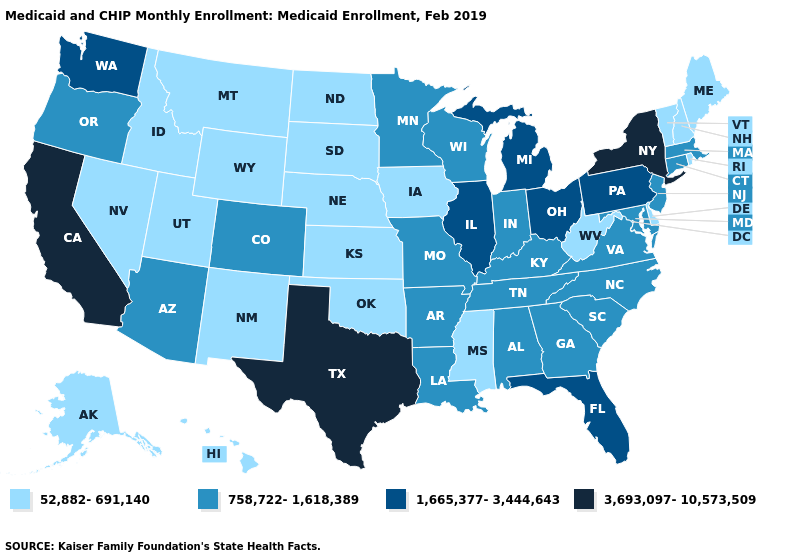Does Alabama have a lower value than Connecticut?
Short answer required. No. What is the highest value in states that border Kansas?
Be succinct. 758,722-1,618,389. Does the map have missing data?
Keep it brief. No. What is the value of West Virginia?
Be succinct. 52,882-691,140. Name the states that have a value in the range 52,882-691,140?
Short answer required. Alaska, Delaware, Hawaii, Idaho, Iowa, Kansas, Maine, Mississippi, Montana, Nebraska, Nevada, New Hampshire, New Mexico, North Dakota, Oklahoma, Rhode Island, South Dakota, Utah, Vermont, West Virginia, Wyoming. What is the value of Tennessee?
Be succinct. 758,722-1,618,389. Does Idaho have the same value as Washington?
Give a very brief answer. No. What is the value of New Jersey?
Keep it brief. 758,722-1,618,389. What is the value of Utah?
Short answer required. 52,882-691,140. Does Missouri have the lowest value in the USA?
Concise answer only. No. Name the states that have a value in the range 3,693,097-10,573,509?
Short answer required. California, New York, Texas. What is the highest value in the Northeast ?
Give a very brief answer. 3,693,097-10,573,509. Which states have the lowest value in the USA?
Keep it brief. Alaska, Delaware, Hawaii, Idaho, Iowa, Kansas, Maine, Mississippi, Montana, Nebraska, Nevada, New Hampshire, New Mexico, North Dakota, Oklahoma, Rhode Island, South Dakota, Utah, Vermont, West Virginia, Wyoming. What is the highest value in the South ?
Keep it brief. 3,693,097-10,573,509. 